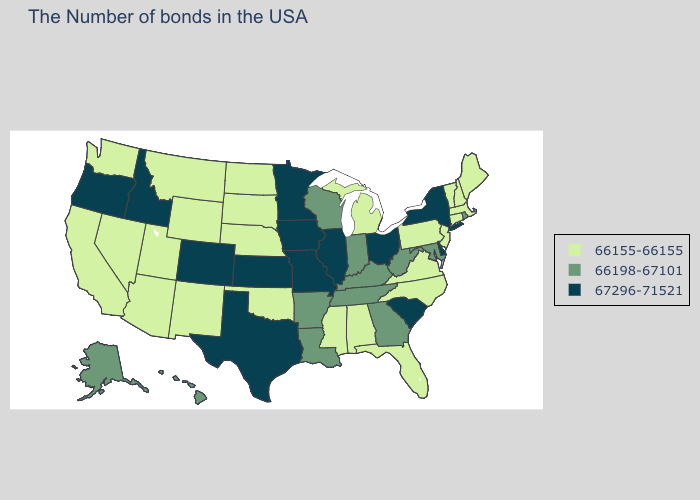Does the map have missing data?
Concise answer only. No. What is the highest value in states that border Wisconsin?
Answer briefly. 67296-71521. Which states have the lowest value in the USA?
Give a very brief answer. Maine, Massachusetts, New Hampshire, Vermont, Connecticut, New Jersey, Pennsylvania, Virginia, North Carolina, Florida, Michigan, Alabama, Mississippi, Nebraska, Oklahoma, South Dakota, North Dakota, Wyoming, New Mexico, Utah, Montana, Arizona, Nevada, California, Washington. Among the states that border Connecticut , which have the highest value?
Short answer required. New York. Does Arkansas have the highest value in the South?
Short answer required. No. Name the states that have a value in the range 66155-66155?
Keep it brief. Maine, Massachusetts, New Hampshire, Vermont, Connecticut, New Jersey, Pennsylvania, Virginia, North Carolina, Florida, Michigan, Alabama, Mississippi, Nebraska, Oklahoma, South Dakota, North Dakota, Wyoming, New Mexico, Utah, Montana, Arizona, Nevada, California, Washington. What is the value of Texas?
Quick response, please. 67296-71521. Does Texas have the same value as South Dakota?
Concise answer only. No. Among the states that border Illinois , does Kentucky have the highest value?
Quick response, please. No. How many symbols are there in the legend?
Be succinct. 3. What is the highest value in states that border Mississippi?
Keep it brief. 66198-67101. How many symbols are there in the legend?
Quick response, please. 3. What is the value of Kentucky?
Keep it brief. 66198-67101. Name the states that have a value in the range 66155-66155?
Write a very short answer. Maine, Massachusetts, New Hampshire, Vermont, Connecticut, New Jersey, Pennsylvania, Virginia, North Carolina, Florida, Michigan, Alabama, Mississippi, Nebraska, Oklahoma, South Dakota, North Dakota, Wyoming, New Mexico, Utah, Montana, Arizona, Nevada, California, Washington. Does Maryland have a lower value than Oregon?
Keep it brief. Yes. 